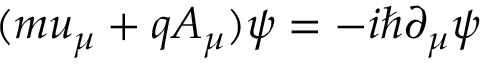Convert formula to latex. <formula><loc_0><loc_0><loc_500><loc_500>( m u _ { \mu } + q A _ { \mu } ) \psi = - i \hbar { \partial } _ { \mu } \psi</formula> 